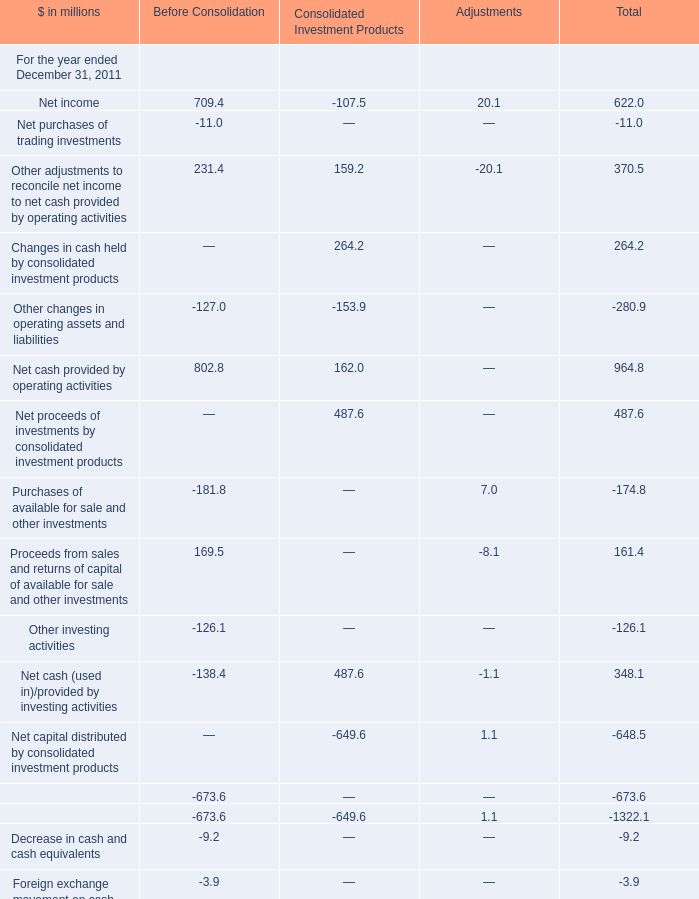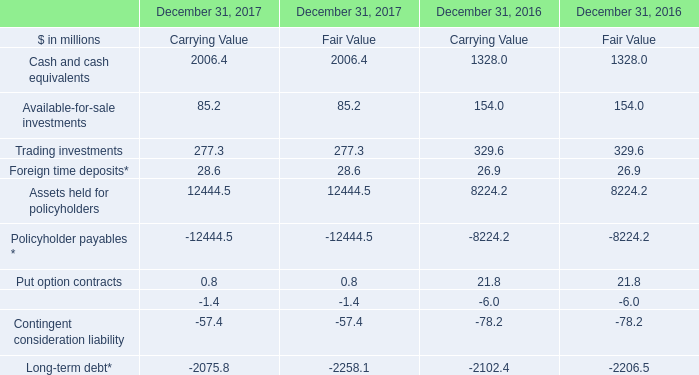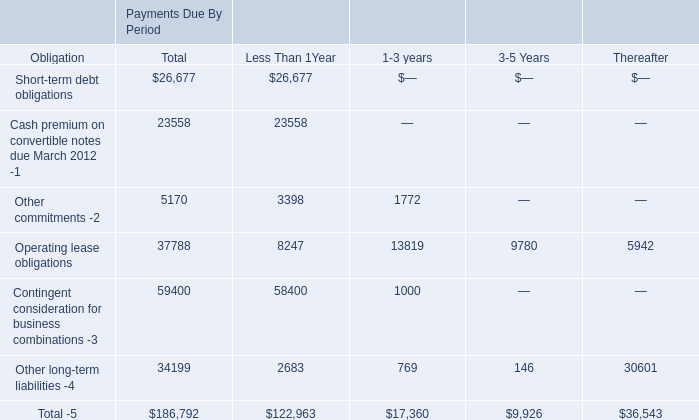What is the Purchases of available for sale and other investments for the section where Net cash provided by operating activities is smaller than 100 million? (in million) 
Answer: 7.0. 